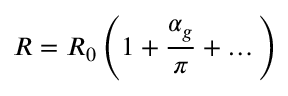Convert formula to latex. <formula><loc_0><loc_0><loc_500><loc_500>R = R _ { 0 } \left ( 1 + { \frac { \alpha _ { g } } { \pi } } + \dots \right )</formula> 